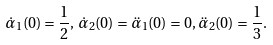Convert formula to latex. <formula><loc_0><loc_0><loc_500><loc_500>\dot { \alpha } _ { 1 } ( 0 ) = \frac { 1 } { 2 } , \, \dot { \alpha } _ { 2 } ( 0 ) = \ddot { \alpha } _ { 1 } ( 0 ) = 0 , \ddot { \alpha } _ { 2 } ( 0 ) = \frac { 1 } { 3 } .</formula> 